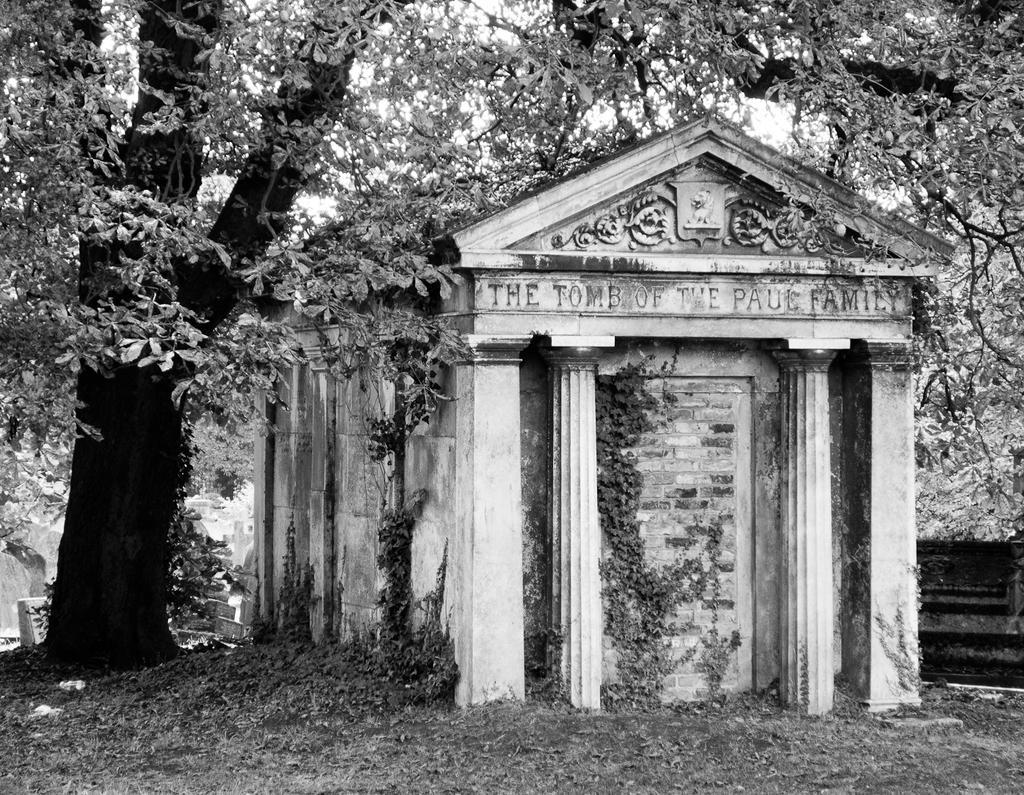Could you give a brief overview of what you see in this image? This is a black and white picture. I can see a tombstone, and in the background there are trees. 